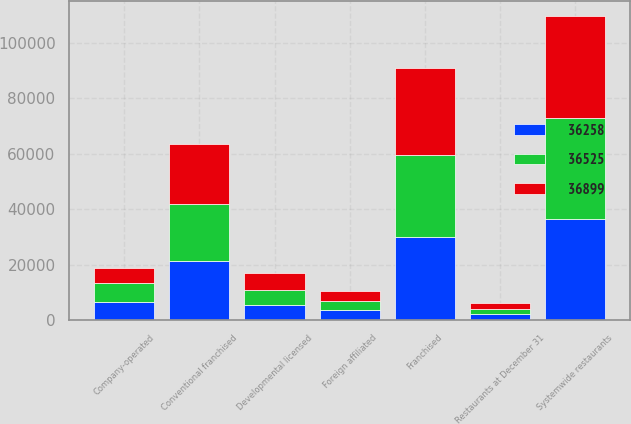Convert chart. <chart><loc_0><loc_0><loc_500><loc_500><stacked_bar_chart><ecel><fcel>Restaurants at December 31<fcel>Conventional franchised<fcel>Developmental licensed<fcel>Foreign affiliated<fcel>Franchised<fcel>Company-operated<fcel>Systemwide restaurants<nl><fcel>36899<fcel>2016<fcel>21559<fcel>6300<fcel>3371<fcel>31230<fcel>5669<fcel>36899<nl><fcel>36258<fcel>2015<fcel>21147<fcel>5529<fcel>3405<fcel>30081<fcel>6444<fcel>36525<nl><fcel>36525<fcel>2014<fcel>20774<fcel>5228<fcel>3542<fcel>29544<fcel>6714<fcel>36258<nl></chart> 